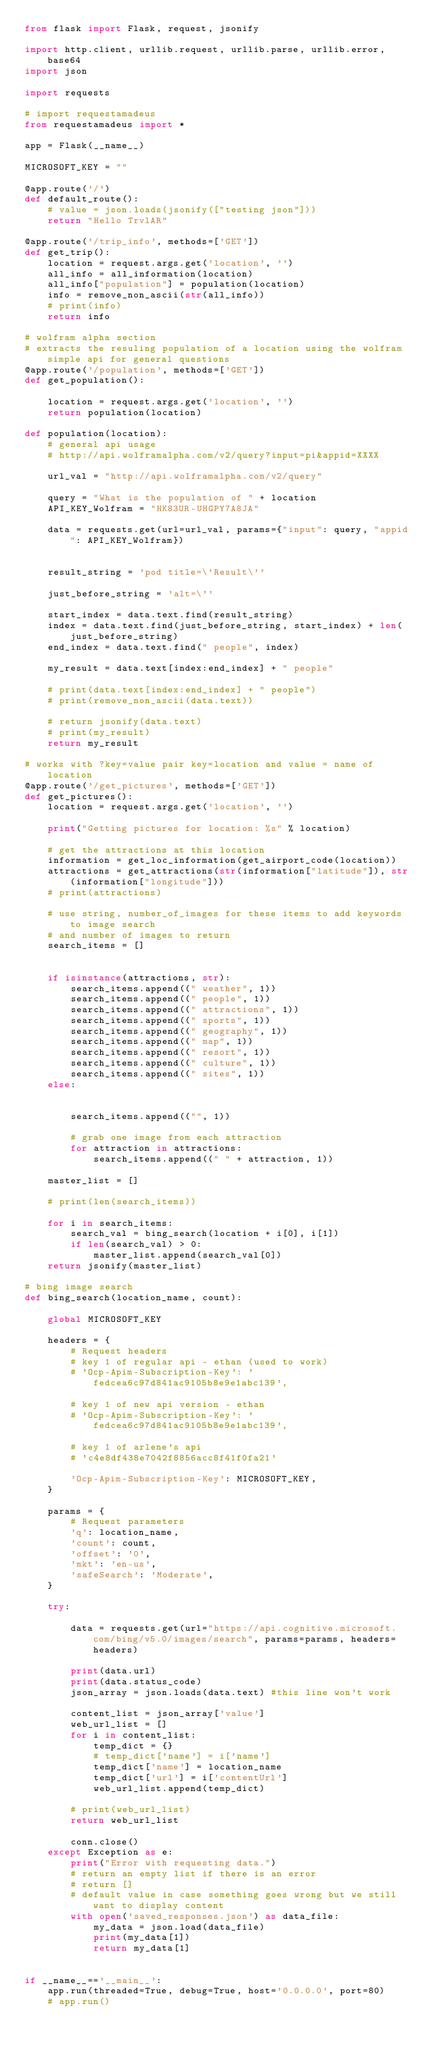Convert code to text. <code><loc_0><loc_0><loc_500><loc_500><_Python_>from flask import Flask, request, jsonify

import http.client, urllib.request, urllib.parse, urllib.error, base64
import json

import requests

# import requestamadeus
from requestamadeus import *

app = Flask(__name__)

MICROSOFT_KEY = ""

@app.route('/')
def default_route():
    # value = json.loads(jsonify(["testing json"]))
    return "Hello TrvlAR"

@app.route('/trip_info', methods=['GET'])
def get_trip():
    location = request.args.get('location', '')
    all_info = all_information(location)
    all_info["population"] = population(location)
    info = remove_non_ascii(str(all_info))
    # print(info)
    return info

# wolfram alpha section
# extracts the resuling population of a location using the wolfram simple api for general questions
@app.route('/population', methods=['GET'])
def get_population():

    location = request.args.get('location', '')
    return population(location)

def population(location):
    # general api usage
    # http://api.wolframalpha.com/v2/query?input=pi&appid=XXXX

    url_val = "http://api.wolframalpha.com/v2/query"

    query = "What is the population of " + location
    API_KEY_Wolfram = "HK83UR-UHGPY7A8JA"

    data = requests.get(url=url_val, params={"input": query, "appid": API_KEY_Wolfram})


    result_string = 'pod title=\'Result\''

    just_before_string = 'alt=\''

    start_index = data.text.find(result_string)
    index = data.text.find(just_before_string, start_index) + len(just_before_string)
    end_index = data.text.find(" people", index)

    my_result = data.text[index:end_index] + " people"

    # print(data.text[index:end_index] + " people")
    # print(remove_non_ascii(data.text))

    # return jsonify(data.text)
    # print(my_result)
    return my_result

# works with ?key=value pair key=location and value = name of location
@app.route('/get_pictures', methods=['GET'])
def get_pictures():
    location = request.args.get('location', '')

    print("Getting pictures for location: %s" % location)

    # get the attractions at this location
    information = get_loc_information(get_airport_code(location))
    attractions = get_attractions(str(information["latitude"]), str(information["longitude"]))
    # print(attractions)

    # use string, number_of_images for these items to add keywords to image search
    # and number of images to return
    search_items = []


    if isinstance(attractions, str):
        search_items.append((" weather", 1))
        search_items.append((" people", 1))
        search_items.append((" attractions", 1))
        search_items.append((" sports", 1))
        search_items.append((" geography", 1))
        search_items.append((" map", 1))
        search_items.append((" resort", 1))
        search_items.append((" culture", 1))
        search_items.append((" sites", 1))
    else:


        search_items.append(("", 1))

        # grab one image from each attraction
        for attraction in attractions:
            search_items.append((" " + attraction, 1))

    master_list = []

    # print(len(search_items))

    for i in search_items:
        search_val = bing_search(location + i[0], i[1])
        if len(search_val) > 0:
            master_list.append(search_val[0])
    return jsonify(master_list)

# bing image search
def bing_search(location_name, count):

    global MICROSOFT_KEY

    headers = {
        # Request headers
        # key 1 of regular api - ethan (used to work)
        # 'Ocp-Apim-Subscription-Key': 'fedcea6c97d841ac9105b8e9e1abc139',

        # key 1 of new api version - ethan
        # 'Ocp-Apim-Subscription-Key': 'fedcea6c97d841ac9105b8e9e1abc139',

        # key 1 of arlene's api
        # 'c4e8df438e7042f8856acc8f41f0fa21'

        'Ocp-Apim-Subscription-Key': MICROSOFT_KEY,
    }

    params = {
        # Request parameters
        'q': location_name,
        'count': count,
        'offset': '0',
        'mkt': 'en-us',
        'safeSearch': 'Moderate',
    }

    try:

        data = requests.get(url="https://api.cognitive.microsoft.com/bing/v5.0/images/search", params=params, headers=headers)

        print(data.url)
        print(data.status_code)
        json_array = json.loads(data.text) #this line won't work

        content_list = json_array['value']
        web_url_list = []
        for i in content_list:
            temp_dict = {}
            # temp_dict['name'] = i['name']
            temp_dict['name'] = location_name
            temp_dict['url'] = i['contentUrl']
            web_url_list.append(temp_dict)

        # print(web_url_list)
        return web_url_list

        conn.close()
    except Exception as e:
        print("Error with requesting data.")
        # return an empty list if there is an error
        # return []
        # default value in case something goes wrong but we still want to display content
        with open('saved_responses.json') as data_file:
            my_data = json.load(data_file)
            print(my_data[1])
            return my_data[1]


if __name__=='__main__':
    app.run(threaded=True, debug=True, host='0.0.0.0', port=80)
    # app.run()
</code> 